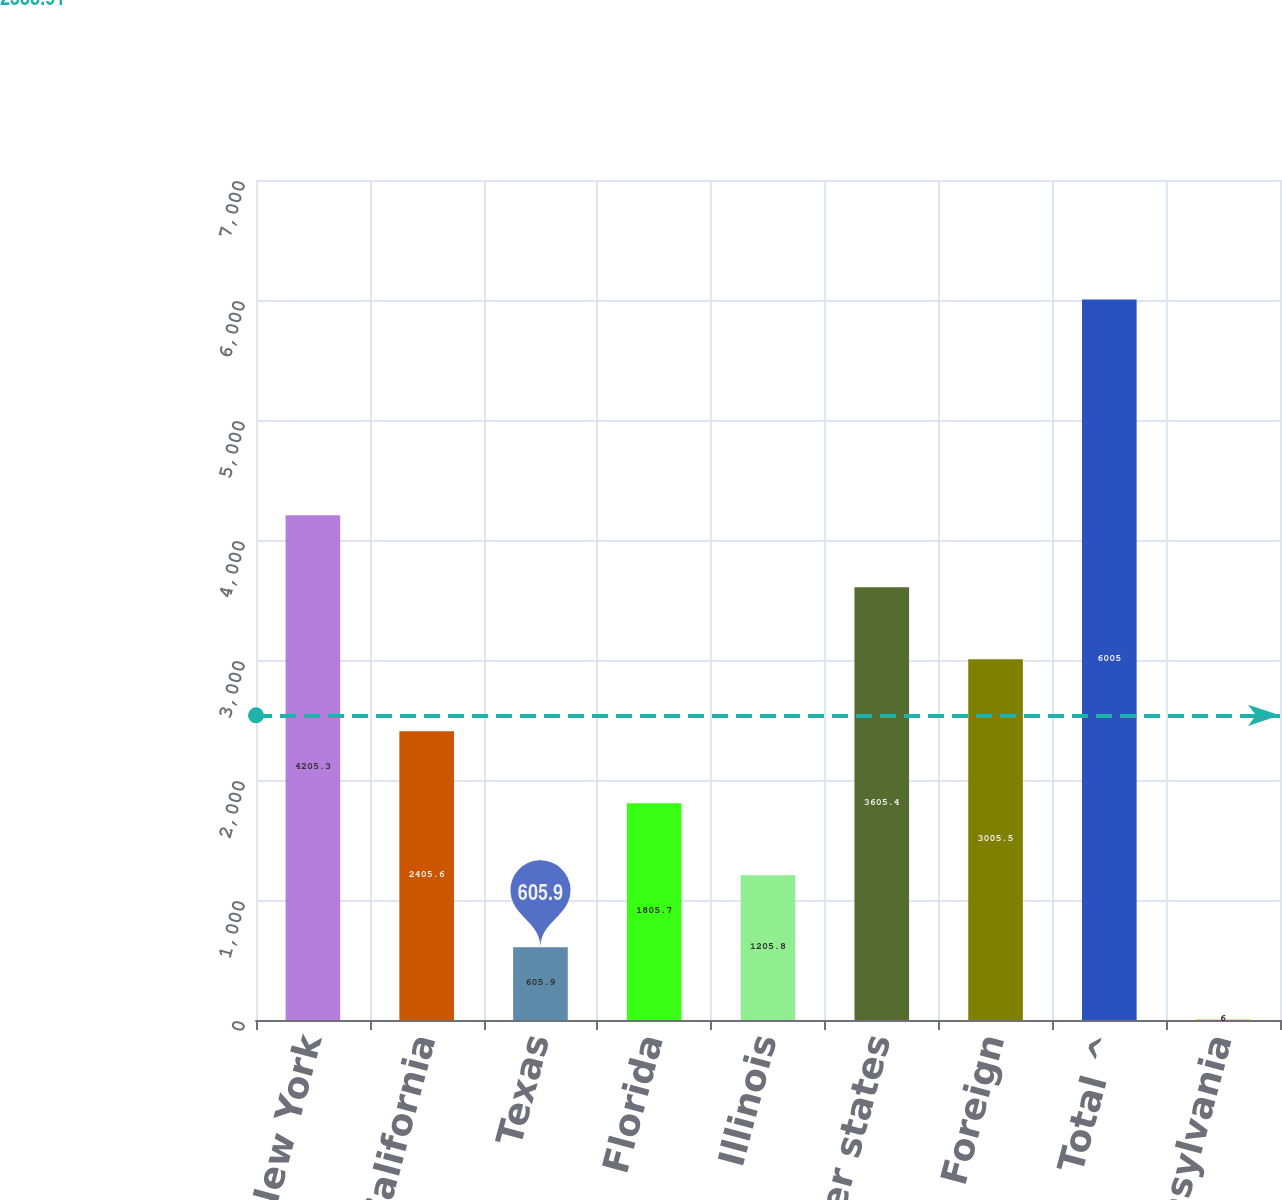Convert chart. <chart><loc_0><loc_0><loc_500><loc_500><bar_chart><fcel>New York<fcel>California<fcel>Texas<fcel>Florida<fcel>Illinois<fcel>Other states<fcel>Foreign<fcel>Total ^<fcel>Pennsylvania<nl><fcel>4205.3<fcel>2405.6<fcel>605.9<fcel>1805.7<fcel>1205.8<fcel>3605.4<fcel>3005.5<fcel>6005<fcel>6<nl></chart> 